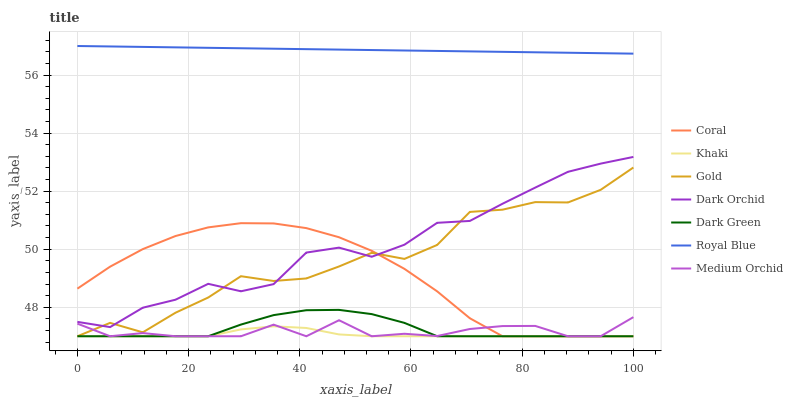Does Khaki have the minimum area under the curve?
Answer yes or no. Yes. Does Royal Blue have the maximum area under the curve?
Answer yes or no. Yes. Does Gold have the minimum area under the curve?
Answer yes or no. No. Does Gold have the maximum area under the curve?
Answer yes or no. No. Is Royal Blue the smoothest?
Answer yes or no. Yes. Is Gold the roughest?
Answer yes or no. Yes. Is Coral the smoothest?
Answer yes or no. No. Is Coral the roughest?
Answer yes or no. No. Does Khaki have the lowest value?
Answer yes or no. Yes. Does Dark Orchid have the lowest value?
Answer yes or no. No. Does Royal Blue have the highest value?
Answer yes or no. Yes. Does Gold have the highest value?
Answer yes or no. No. Is Khaki less than Dark Orchid?
Answer yes or no. Yes. Is Royal Blue greater than Coral?
Answer yes or no. Yes. Does Medium Orchid intersect Gold?
Answer yes or no. Yes. Is Medium Orchid less than Gold?
Answer yes or no. No. Is Medium Orchid greater than Gold?
Answer yes or no. No. Does Khaki intersect Dark Orchid?
Answer yes or no. No. 